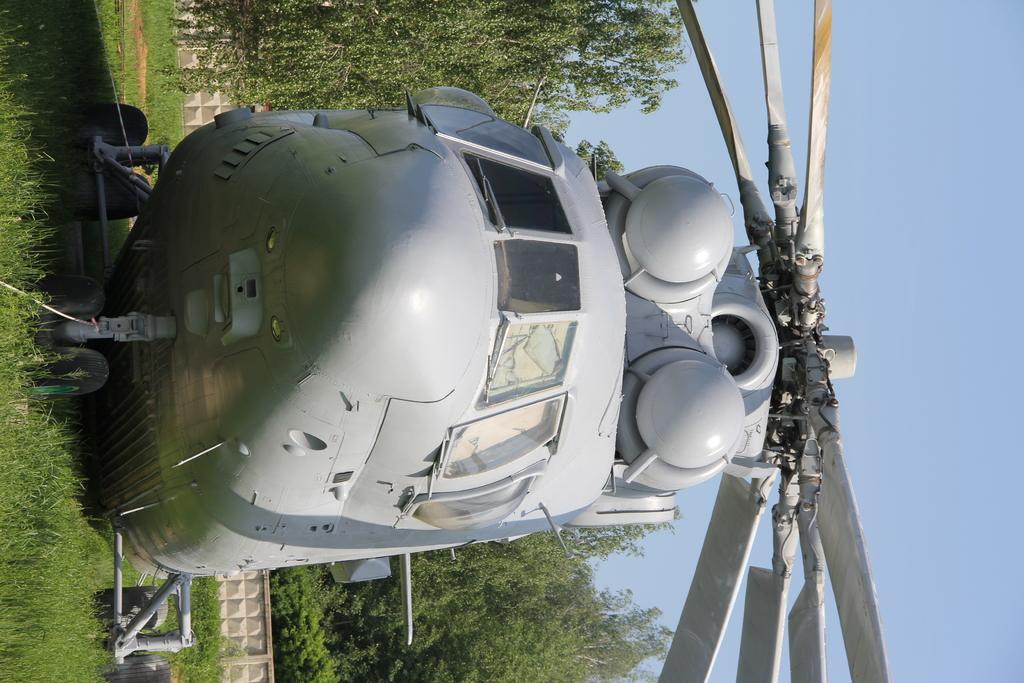What is located on the grass in the image? There is an aircraft on the grass. What can be seen in the background of the image? There is a wall, trees, and the sky visible in the background of the image. How many roses are on the aircraft in the image? There are no roses present on the aircraft in the image. Can you see a ladybug crawling on the wall in the background? There is no ladybug visible on the wall or anywhere else in the image. 